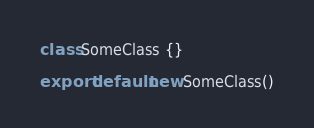Convert code to text. <code><loc_0><loc_0><loc_500><loc_500><_JavaScript_>class SomeClass {}

export default new SomeClass()
</code> 